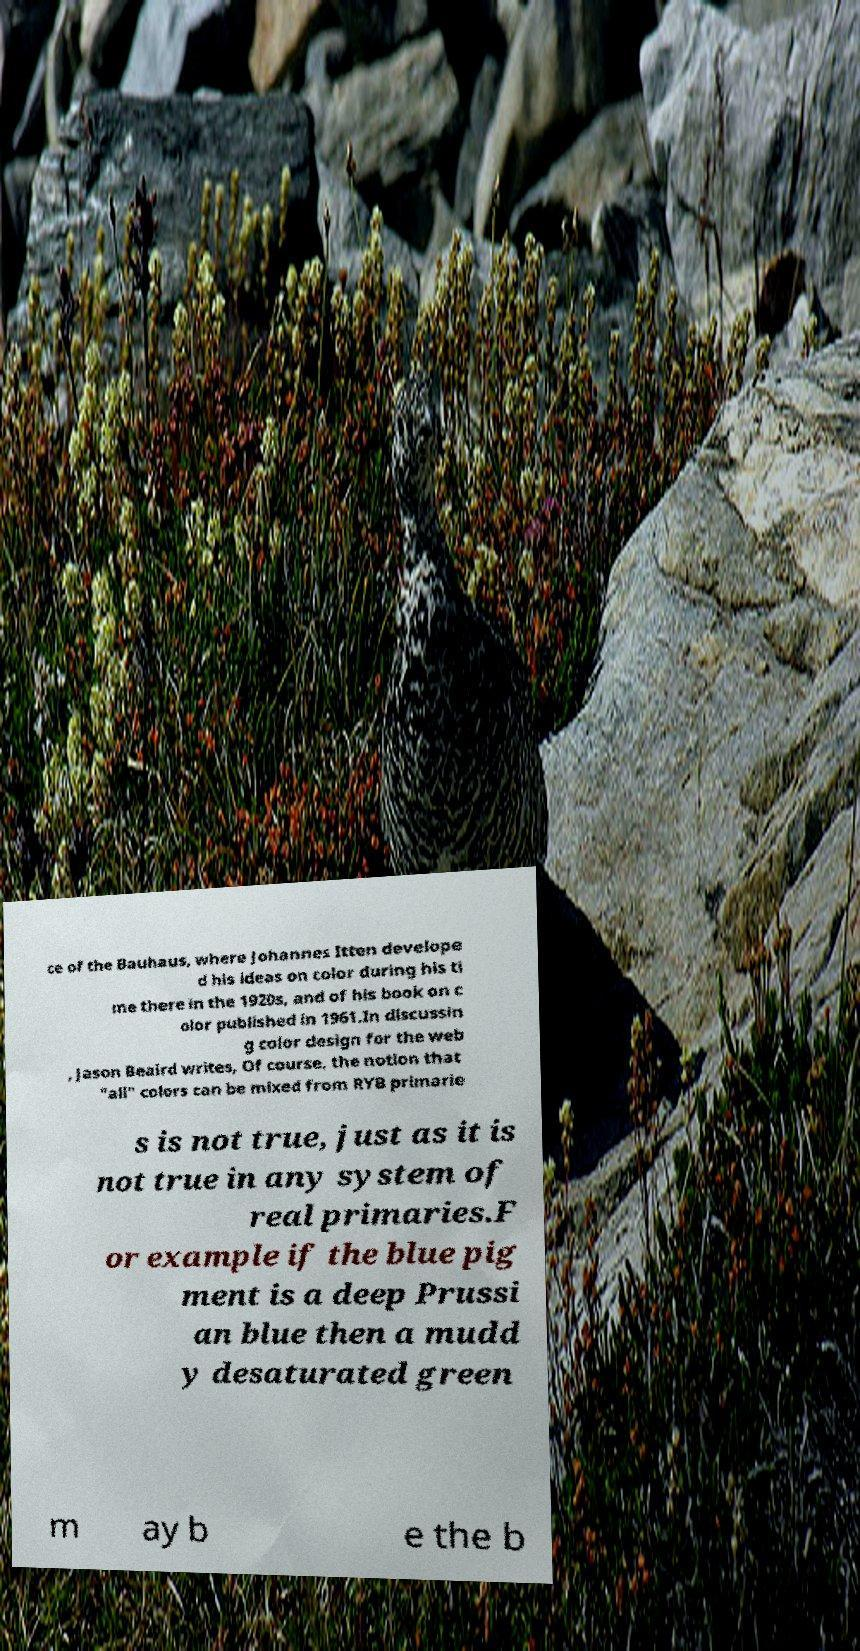Can you accurately transcribe the text from the provided image for me? ce of the Bauhaus, where Johannes Itten develope d his ideas on color during his ti me there in the 1920s, and of his book on c olor published in 1961.In discussin g color design for the web , Jason Beaird writes, Of course, the notion that "all" colors can be mixed from RYB primarie s is not true, just as it is not true in any system of real primaries.F or example if the blue pig ment is a deep Prussi an blue then a mudd y desaturated green m ay b e the b 